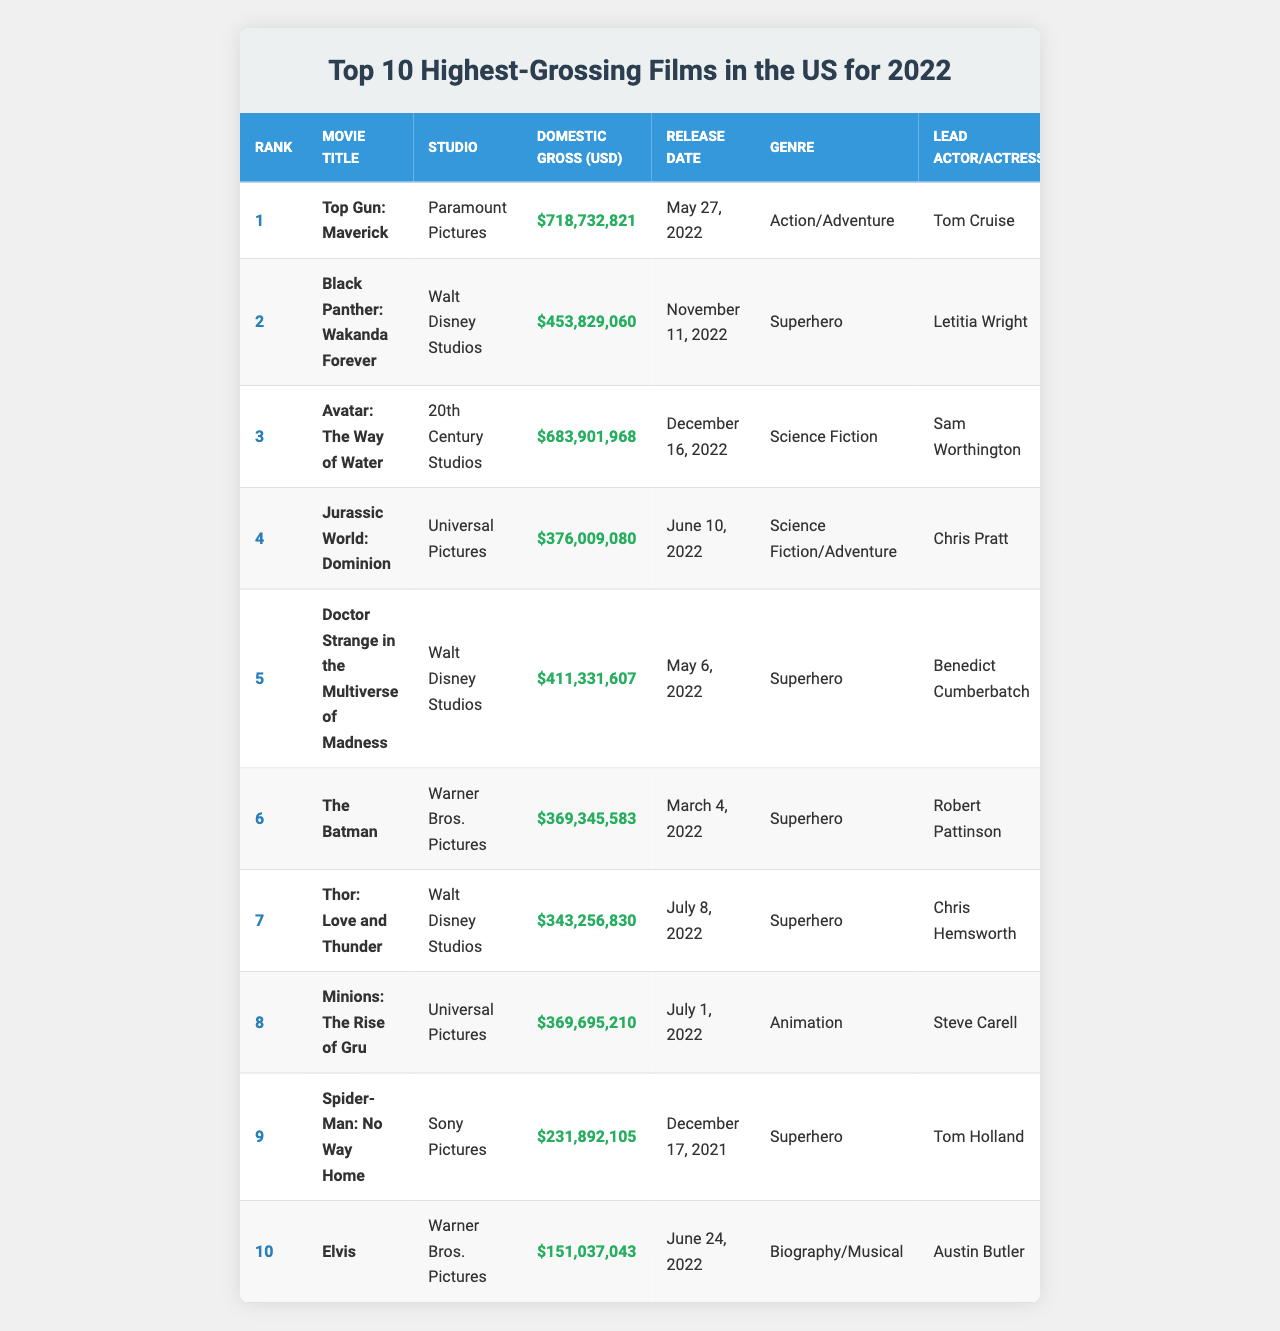What is the highest-grossing film in the US for 2022? The table shows that "Top Gun: Maverick" is ranked 1st with a domestic gross of $718,732,821, making it the highest-grossing film in the US for 2022.
Answer: Top Gun: Maverick Which studio produced "Black Panther: Wakanda Forever"? According to the table, "Black Panther: Wakanda Forever" was produced by Walt Disney Studios.
Answer: Walt Disney Studios How much did "Avatar: The Way of Water" earn in domestic gross? The table indicates that "Avatar: The Way of Water" earned $683,901,968 in domestic gross.
Answer: $683,901,968 What is the release date of "Doctor Strange in the Multiverse of Madness"? The table lists "Doctor Strange in the Multiverse of Madness" with a release date of May 6, 2022.
Answer: May 6, 2022 Which film had a domestic gross of over $400 million but less than $500 million? The movie "Doctor Strange in the Multiverse of Madness" earned $411,331,607, which is over $400 million but under $500 million.
Answer: Doctor Strange in the Multiverse of Madness What is the total domestic gross of the top three films? Adding the domestic grosses: $718,732,821 (Top Gun: Maverick) + $683,901,968 (Avatar: The Way of Water) + $453,829,060 (Black Panther: Wakanda Forever) gives a total of $1,856,463,849.
Answer: $1,856,463,849 Which film has the lowest domestic gross among the top 10? The table shows that "Elvis" has the lowest domestic gross at $151,037,043 compared to other films in the list.
Answer: Elvis Can you name all superhero films among the top 10 highest-grossing films? The superhero films listed are "Black Panther: Wakanda Forever," "Doctor Strange in the Multiverse of Madness," "The Batman," "Thor: Love and Thunder," and "Spider-Man: No Way Home."
Answer: 5 What percentage of the total domestic gross in the top 10 does "Top Gun: Maverick" represent? First, the total domestic gross of the top 10 films is calculated to be $3,028,823,151. Then, we find "Top Gun: Maverick" grossed $718,732,821. The percentage is ($718,732,821 / $3,028,823,151) * 100 = approximately 23.7%.
Answer: 23.7% Is "Minions: The Rise of Gru" among the top five highest-grossing films? The table confirms that "Minions: The Rise of Gru" is ranked 8th, which places it outside the top five highest-grossing films.
Answer: No 